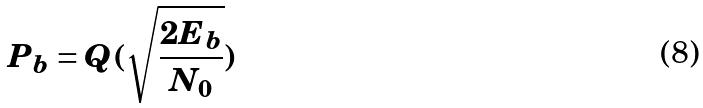<formula> <loc_0><loc_0><loc_500><loc_500>P _ { b } = Q ( \sqrt { \frac { 2 E _ { b } } { N _ { 0 } } } )</formula> 